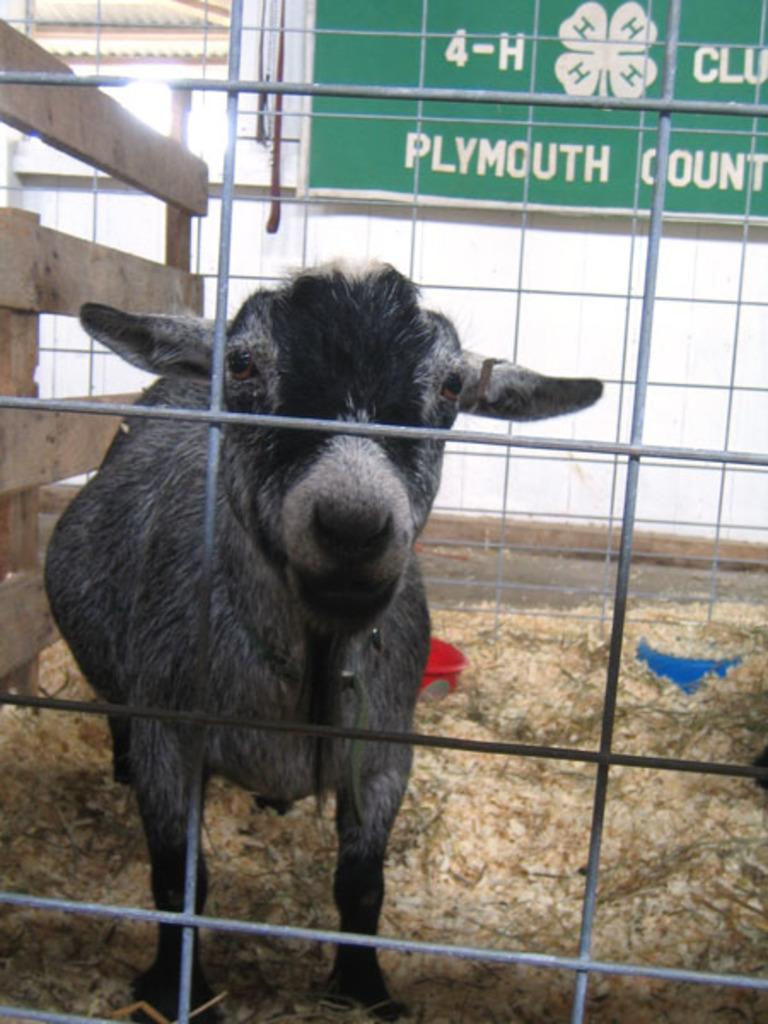What type of animal is in the image? There is an animal in the image, but its specific type cannot be determined from the provided facts. What color is the animal in the image? The animal is black and white in color. What position is the animal in? The animal is standing. What surrounds the animal in the image? There is a fence around the animal. What can be seen in the background of the image? There is a boat in the background of the image. What is written on the boat? There is writing on the boat. What type of education does the animal in the image have? There is no information about the animal's education in the image. Can you see a swing in the image? There is no swing present in the image. 